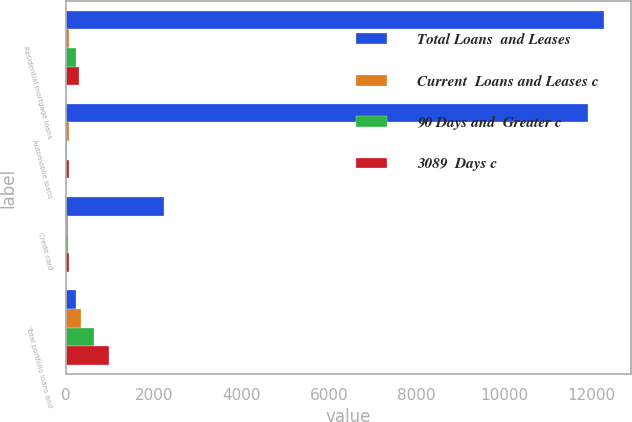<chart> <loc_0><loc_0><loc_500><loc_500><stacked_bar_chart><ecel><fcel>Residential mortgage loans<fcel>Automobile loans<fcel>Credit card<fcel>Total portfolio loans and<nl><fcel>Total Loans  and Leases<fcel>12284<fcel>11919<fcel>2225<fcel>231<nl><fcel>Current  Loans and Leases c<fcel>73<fcel>55<fcel>36<fcel>345<nl><fcel>90 Days and  Greater c<fcel>231<fcel>10<fcel>33<fcel>643<nl><fcel>3089  Days c<fcel>304<fcel>65<fcel>69<fcel>988<nl></chart> 